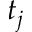Convert formula to latex. <formula><loc_0><loc_0><loc_500><loc_500>t _ { j }</formula> 